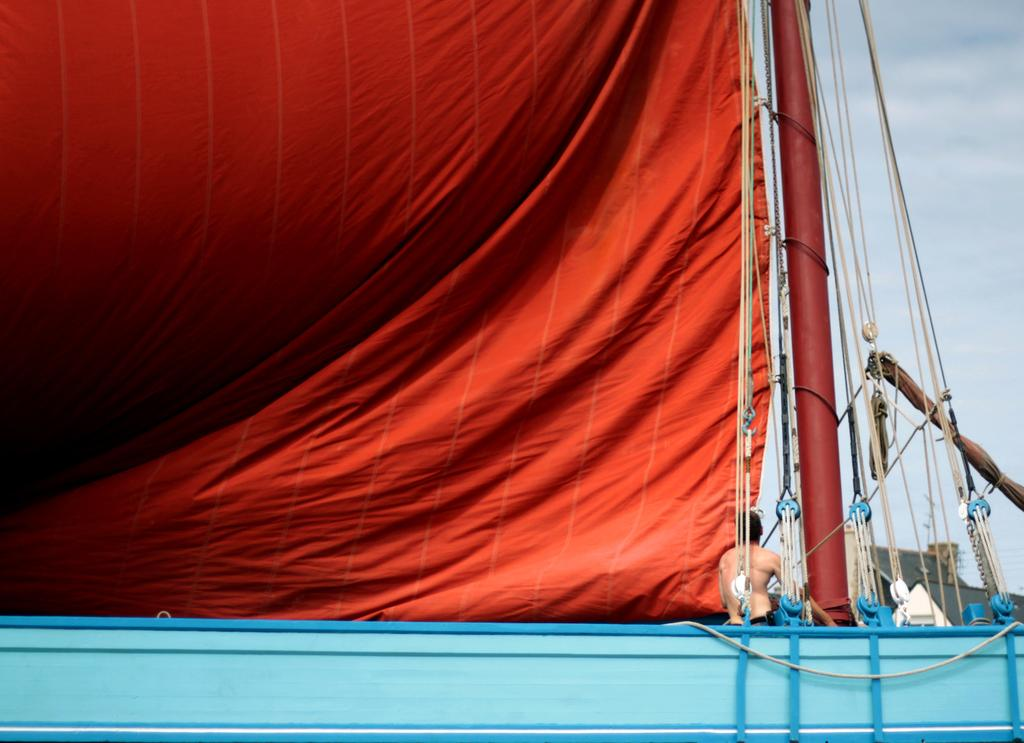What is the condition of the sky in the image? The sky is cloudy in the image. Can you describe the person in the image? There is a person in the image, but no specific details about their appearance or actions are provided. What color is the cloth in the image? The cloth in the image is red. Where is the crate located in the image? There is no crate present in the image. What time does the clock show in the image? There is no clock present in the image. 